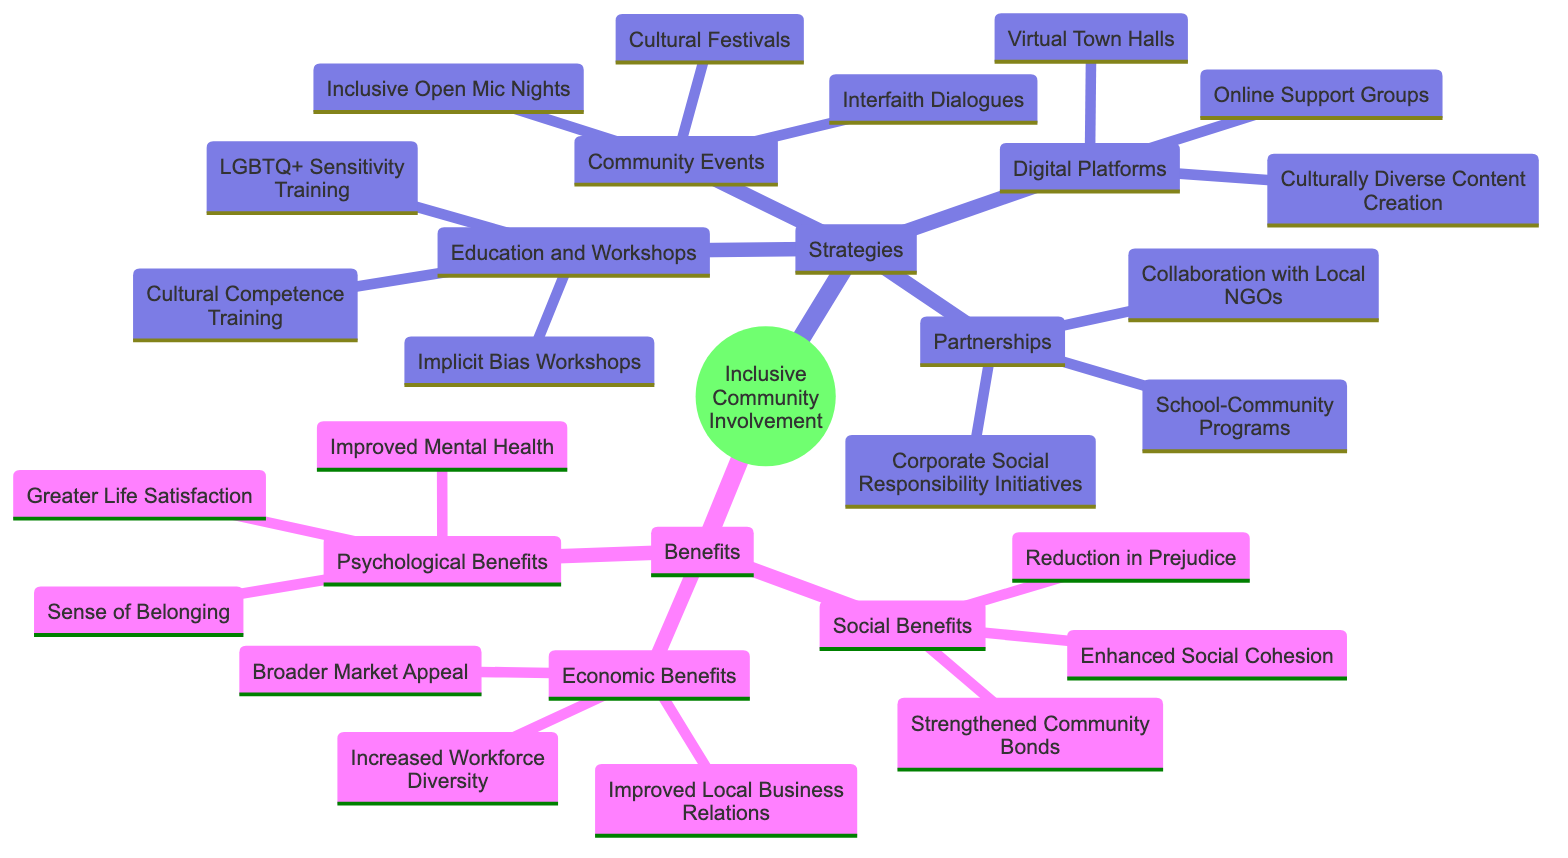What are the four main strategies listed in the diagram? The diagram highlights four main strategies under the "Strategies" node. By locating this node and identifying its immediate children, we can see the strategies: "Education and Workshops," "Community Events," "Partnerships," and "Digital Platforms."
Answer: Education and Workshops, Community Events, Partnerships, Digital Platforms How many types of benefits are there in the diagram? The diagram mentions a "Benefits" node that has three immediate children: "Social Benefits," "Economic Benefits," and "Psychological Benefits." Therefore, by counting these children, we find there are three types of benefits.
Answer: 3 Which strategy includes "Cultural Festivals"? To find this, we identify the node "Cultural Festivals" and then trace back to its parent. This node is located under the "Community Events" category, which is one of the strategies listed.
Answer: Community Events What is one economic benefit mentioned in the diagram? The "Economic Benefits" category includes several immediate children. By looking at this node, we can select any of them as an answer. One example is "Increased Workforce Diversity."
Answer: Increased Workforce Diversity How are "Implicit Bias Workshops" related to "Education and Workshops"? The "Implicit Bias Workshops" is a child node of the "Education and Workshops" strategy node. It is categorized under educational strategies intended to promote inclusivity. Thus, they are directly related as part of the same strategy.
Answer: Education and Workshops What is the relationship between "Online Support Groups" and "Digital Platforms"? The "Online Support Groups" node extends from the "Digital Platforms" category. This indicates that it is one of the strategies employed to foster community involvement through digital means.
Answer: Digital Platforms What type of benefit is "Sense of Belonging"? The "Sense of Belonging" node is found under the "Psychological Benefits" category. This clearly indicates that it represents a psychological aspect of community involvement benefits.
Answer: Psychological Benefits Which strategy would you find "Culturally Diverse Content Creation"? By locating "Culturally Diverse Content Creation," we find it is a part of the "Digital Platforms" strategy. This means that this strategy focuses on creating content that reflects diverse cultures.
Answer: Digital Platforms 